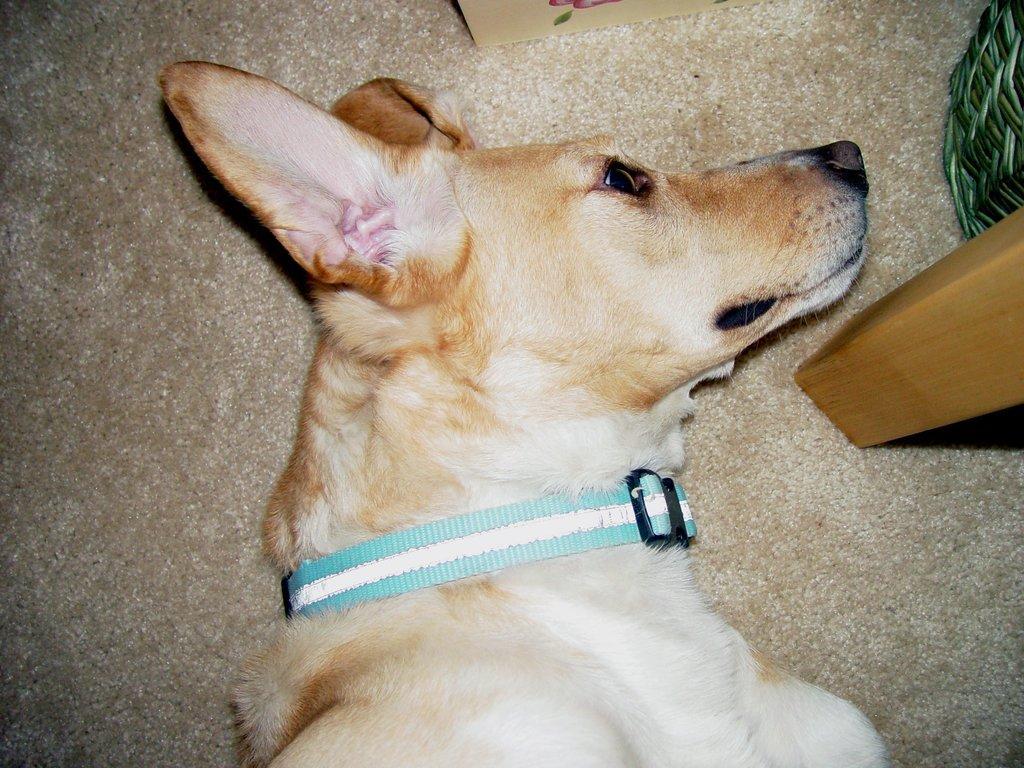What type of animal is in the image? There is a dog in the image. Can you describe the color of the dog? The dog is white and pale brown in color. What is attached to the dog in the image? There is a dog belt visible in the image. What can be seen on the floor in the image? The floor is visible in the image. What other objects are present in the image? There is a wooden pole and a basket in the image. What type of shop can be seen in the image? There is no shop present in the image; it features a dog with a dog belt, a wooden pole, a basket, and a visible floor. What is the current temperature in the image? The image does not provide information about the temperature, as it is a still photograph and not a live video or recording. 